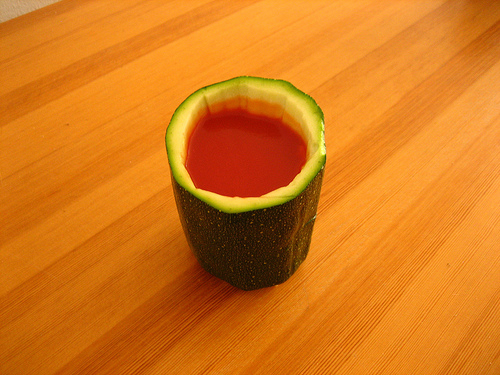<image>
Can you confirm if the vegetable is in front of the juice? No. The vegetable is not in front of the juice. The spatial positioning shows a different relationship between these objects. 